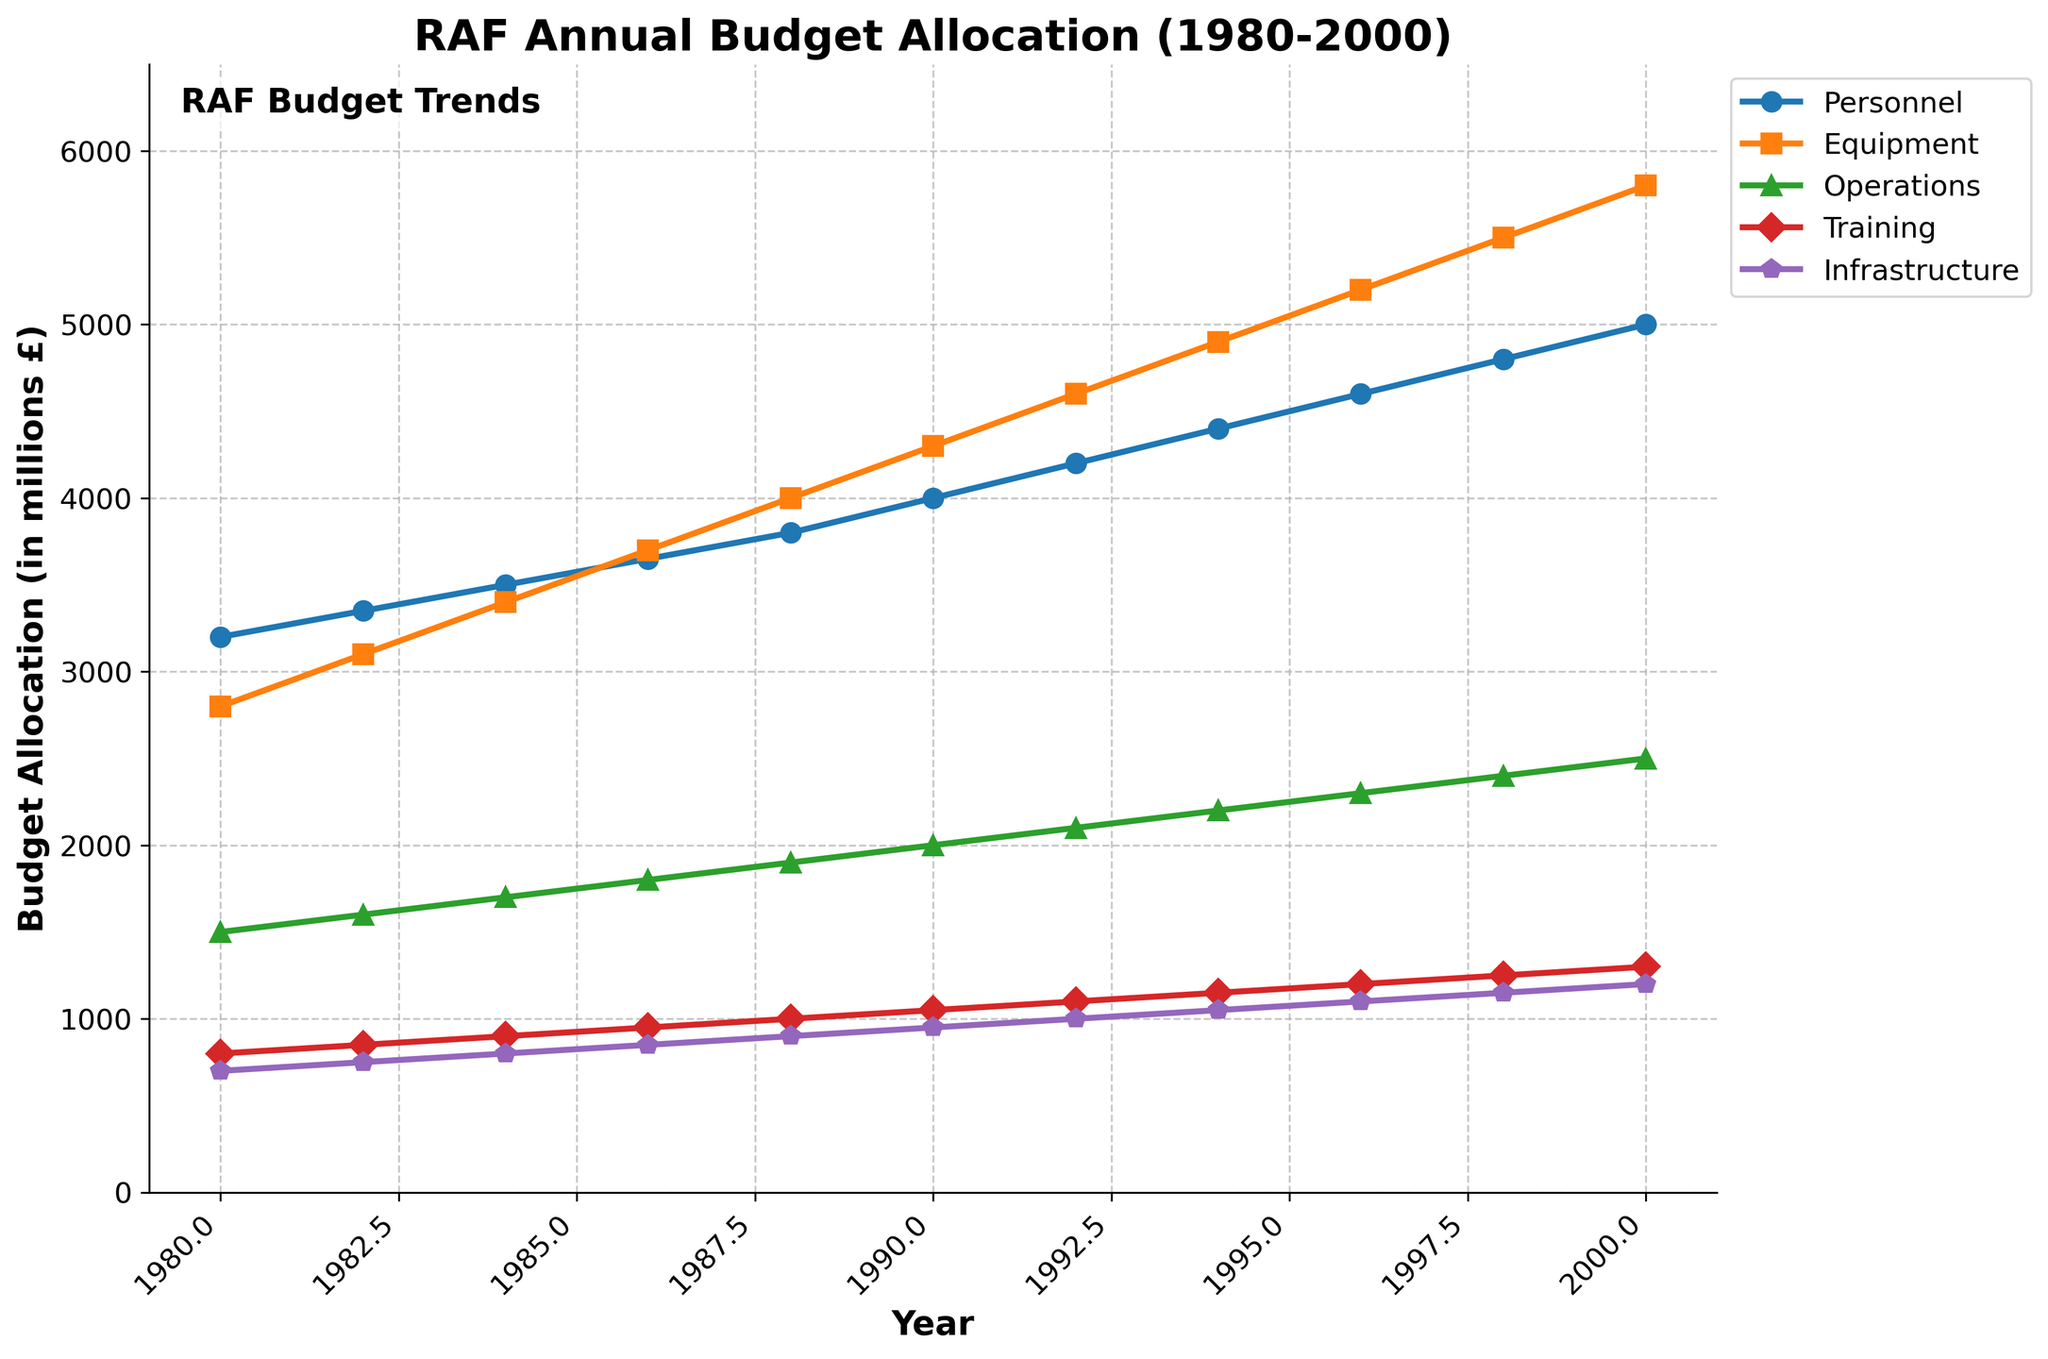How did the budget allocation for Equipment change from 1980 to 2000? To compare the budget allocation for Equipment from 1980 to 2000, look at the starting value in 1980 and the ending value in 2000. In 1980, the Equipment budget was £2800 million, and in 2000, it was £5800 million. The change is £5800 million - £2800 million = £3000 million.
Answer: Increased by £3000 million In which year did the Training budget first exceed £1000 million? Observe the Training budget trend and identify the first year where the allocation surpasses £1000 million. From 1980 to 1992, the budget was below or equal to £1000 million. It first exceeds that amount in 1994 with £1150 million.
Answer: 1994 Which category had the highest budget allocation in 1990? In the year 1990, examine the different budget categories and identify the one with the highest value. Personnel: £4000 million, Equipment: £4300 million, Operations: £2000 million, Training: £1050 million, Infrastructure: £950 million. The Equipment category has the highest budget for 1990.
Answer: Equipment What was the total budget allocation for all categories in the year 2000? Sum up the budget allocations for all categories in the year 2000. Personnel: £5000 million, Equipment: £5800 million, Operations: £2500 million, Training: £1300 million, Infrastructure: £1200 million. Total = £5000 + £5800 + £2500 + £1300 + £1200 = £16800 million.
Answer: £16800 million Compare the growth rate of the Personnel budget to the Infrastructure budget from 1980 to 2000. Calculate the growth rate for Personnel and Infrastructure by dividing the difference in budget by the initial budget for each category. Personnel growth rate: (£5000-£3200)/£3200 = 1.5625. Infrastructure growth rate: (£1200-£700)/£700 = 0.7143. Compare these growth rates: Personnel (1.5625) vs. Infrastructure (0.7143).
Answer: Personnel grew faster Between which two consecutive years was the largest increase in the Equipment budget observed? Determine the increase in the Equipment budget between each consecutive year and identify the maximum increase. The largest increases are from 1988 to 1990 (4000 to 4300, increase of 300) and from 1998 to 2000 (5500 to 5800, increase of 300).
Answer: 1988 to 1990 and 1998 to 2000 In the year 1988, how much higher was the budget for Equipment compared to Operations? Compare the Equipment and Operations budgets for the year 1988. Equipment: £4000 million, Operations: £1900 million. Difference = £4000 - £1900 = £2100 million.
Answer: £2100 million What visual trend can you observe for the Training budget over the given period? Identify the overall trend in the Training budget by observing its graphical representation from 1980 to 2000. The Training budget shows a consistent and steady increase over this period.
Answer: Steady increase What is the average annual budget allocation for Personnel over the entire period? Sum the annual Personnel budgets from 1980 to 2000 and divide by the number of years. Total Personnel budget = 3200+3350+3500+3650+3800+4000+4200+4400+4600+4800+5000 = £43500 million. Average = £43500/11 ≈ £3955 million.
Answer: £3955 million 